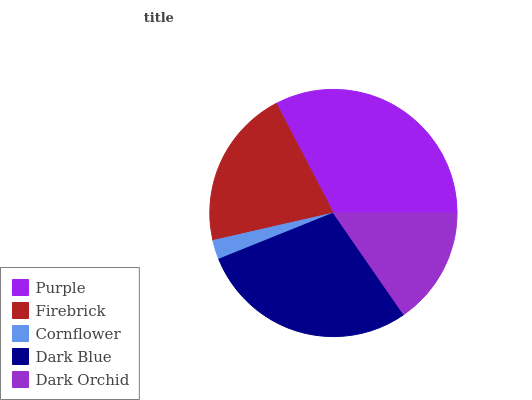Is Cornflower the minimum?
Answer yes or no. Yes. Is Purple the maximum?
Answer yes or no. Yes. Is Firebrick the minimum?
Answer yes or no. No. Is Firebrick the maximum?
Answer yes or no. No. Is Purple greater than Firebrick?
Answer yes or no. Yes. Is Firebrick less than Purple?
Answer yes or no. Yes. Is Firebrick greater than Purple?
Answer yes or no. No. Is Purple less than Firebrick?
Answer yes or no. No. Is Firebrick the high median?
Answer yes or no. Yes. Is Firebrick the low median?
Answer yes or no. Yes. Is Dark Blue the high median?
Answer yes or no. No. Is Dark Blue the low median?
Answer yes or no. No. 